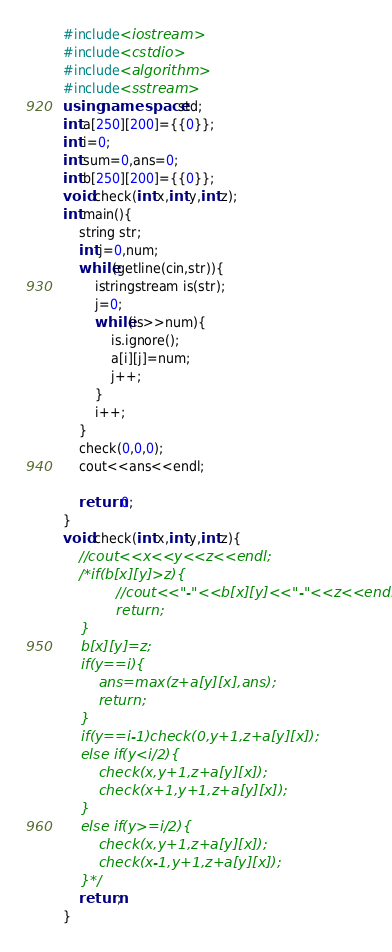<code> <loc_0><loc_0><loc_500><loc_500><_C++_>#include<iostream>
#include<cstdio>
#include<algorithm>
#include<sstream>
using namespace std;
int a[250][200]={{0}};
int i=0;
int sum=0,ans=0;
int b[250][200]={{0}};
void check(int x,int y,int z);
int main(){
    string str;
    int j=0,num;
    while(getline(cin,str)){
        istringstream is(str);
        j=0;
        while(is>>num){
            is.ignore();
            a[i][j]=num;
            j++;
        }
        i++;
    }
    check(0,0,0);
    cout<<ans<<endl;

    return 0;
}
void check(int x,int y,int z){
    //cout<<x<<y<<z<<endl;
    /*if(b[x][y]>z){
            //cout<<"-"<<b[x][y]<<"-"<<z<<endl;
            return;
    }
    b[x][y]=z;
    if(y==i){
        ans=max(z+a[y][x],ans);
        return;
    }
    if(y==i-1)check(0,y+1,z+a[y][x]);
    else if(y<i/2){
        check(x,y+1,z+a[y][x]);
        check(x+1,y+1,z+a[y][x]);
    }
    else if(y>=i/2){
        check(x,y+1,z+a[y][x]);
        check(x-1,y+1,z+a[y][x]);
    }*/
    return;
}</code> 